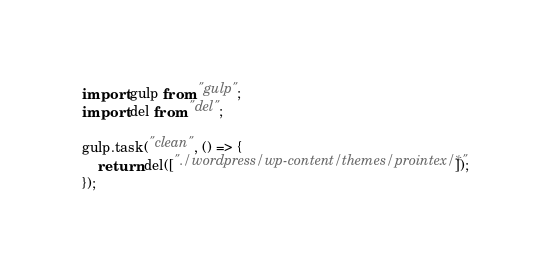Convert code to text. <code><loc_0><loc_0><loc_500><loc_500><_JavaScript_>import gulp from "gulp";
import del from "del";

gulp.task("clean", () => {
    return del(["./wordpress/wp-content/themes/prointex/*"]);
});</code> 